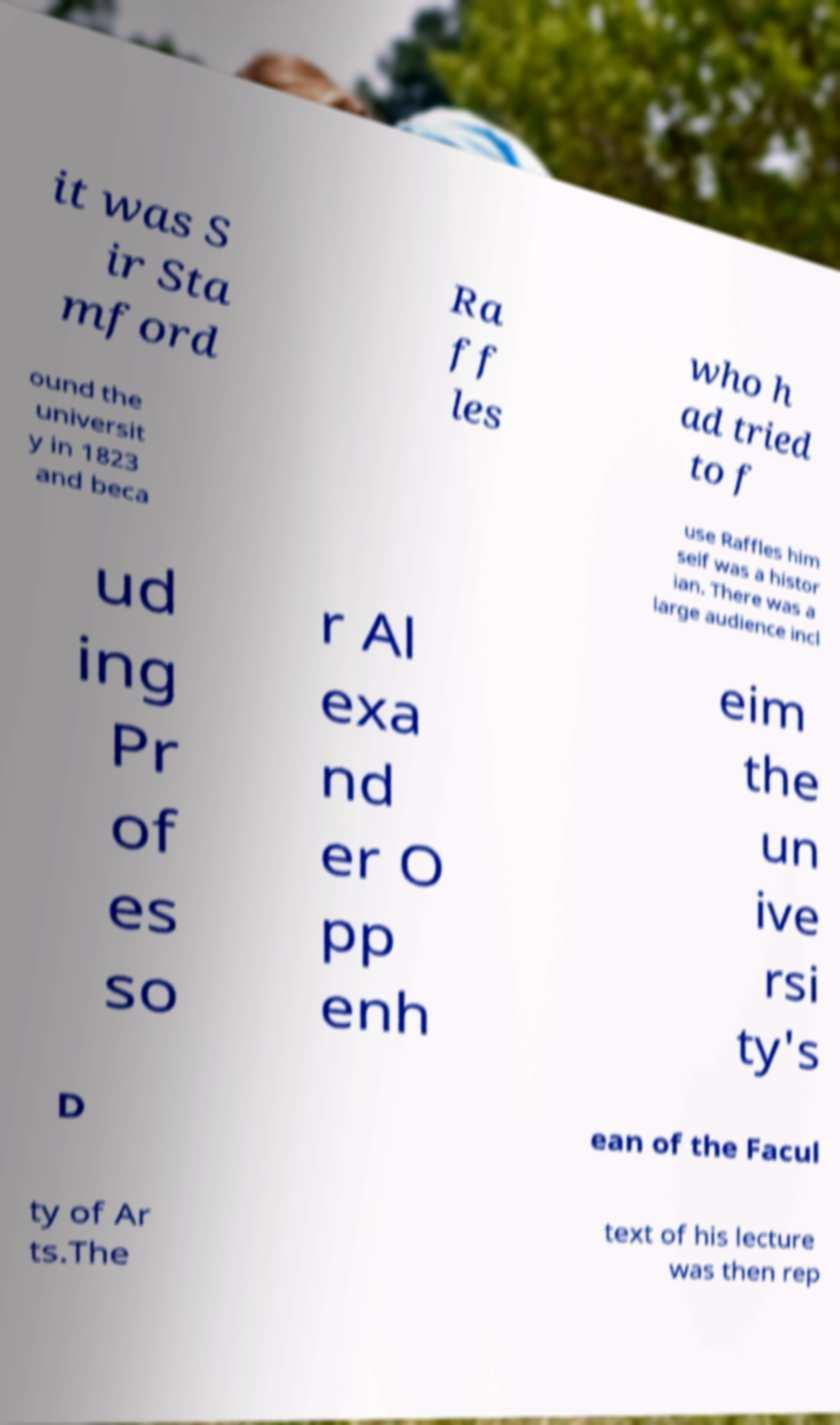There's text embedded in this image that I need extracted. Can you transcribe it verbatim? it was S ir Sta mford Ra ff les who h ad tried to f ound the universit y in 1823 and beca use Raffles him self was a histor ian. There was a large audience incl ud ing Pr of es so r Al exa nd er O pp enh eim the un ive rsi ty's D ean of the Facul ty of Ar ts.The text of his lecture was then rep 